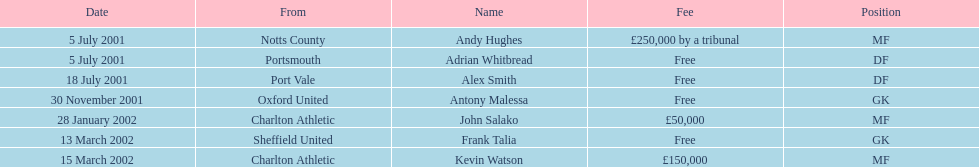Who transferred after 30 november 2001? John Salako, Frank Talia, Kevin Watson. 